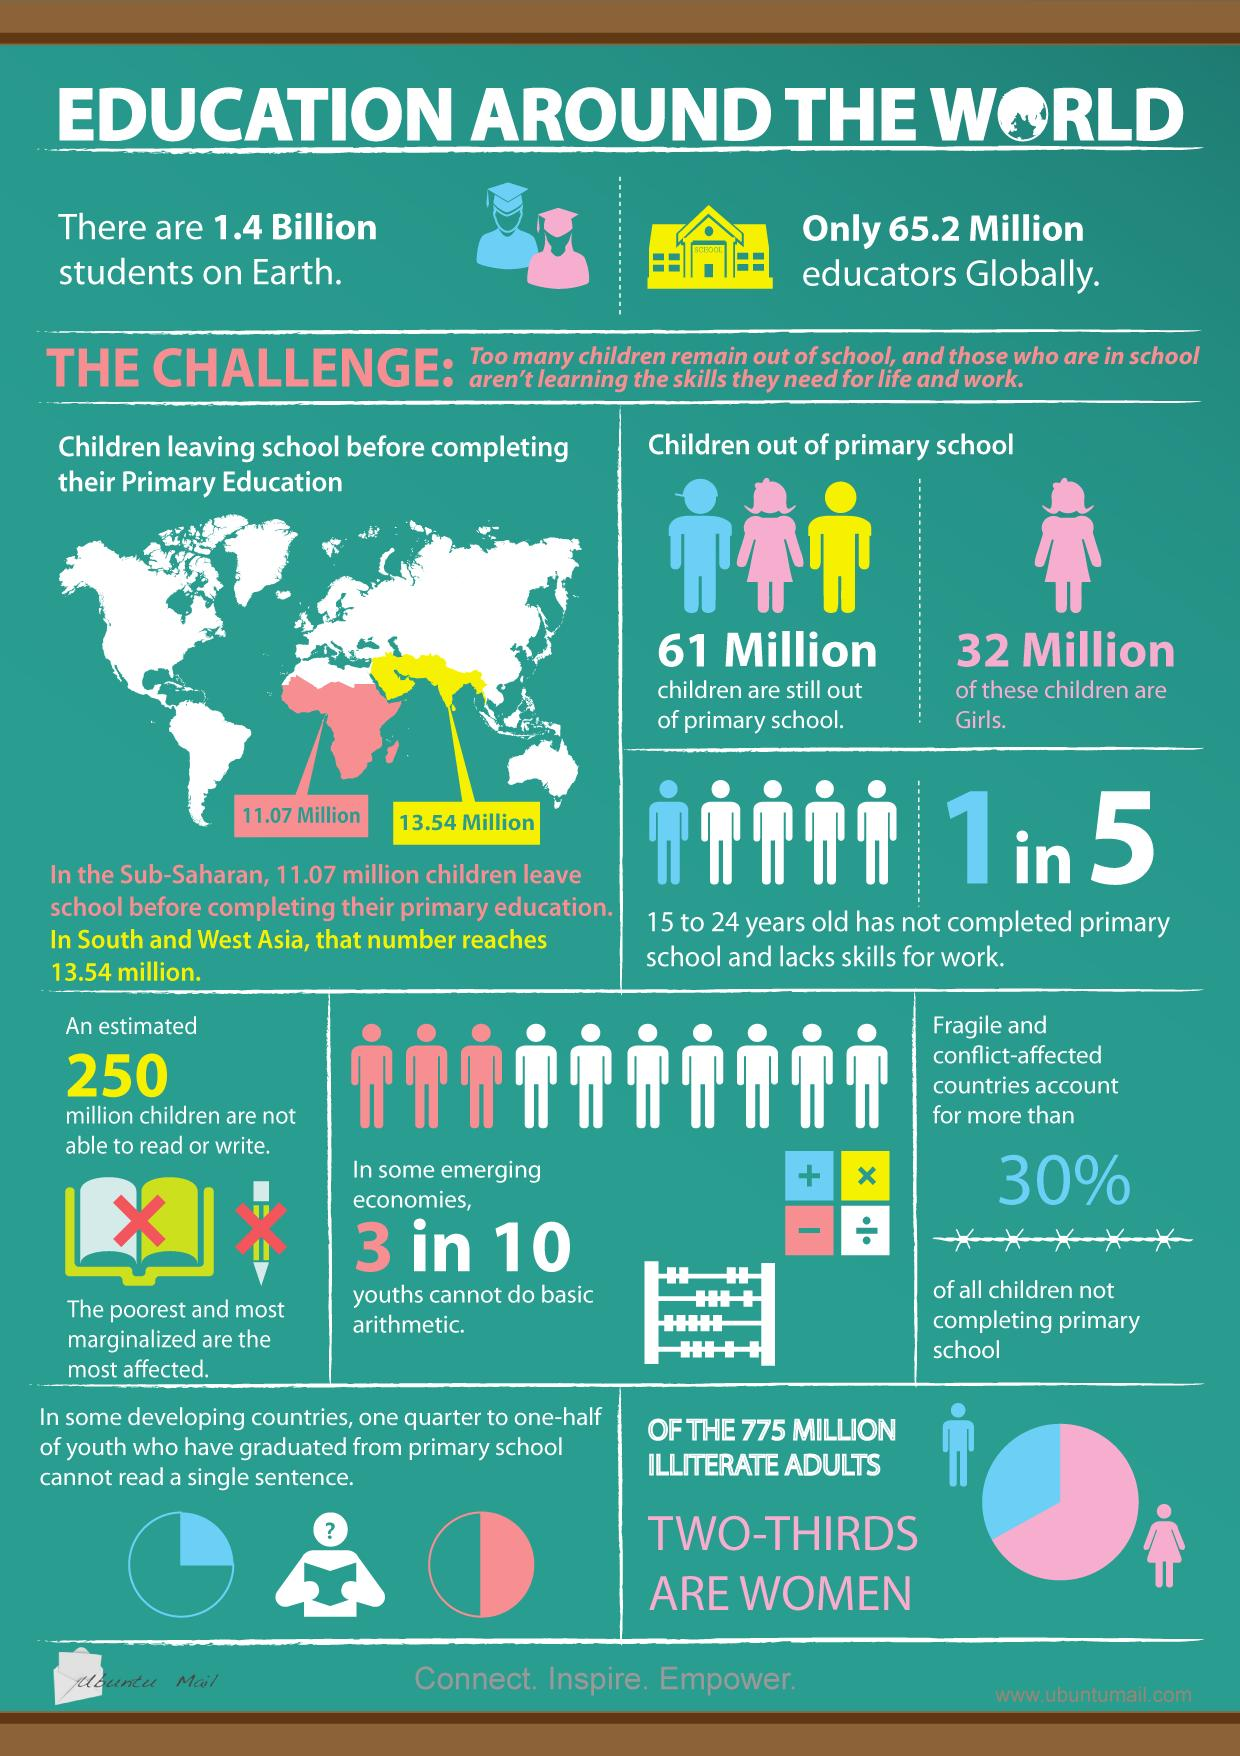Mention a couple of crucial points in this snapshot. There are currently 61 million children around the world who are still out of primary school. An estimated 250 million children worldwide are unable to read or write, representing a significant challenge to global education and development efforts. 